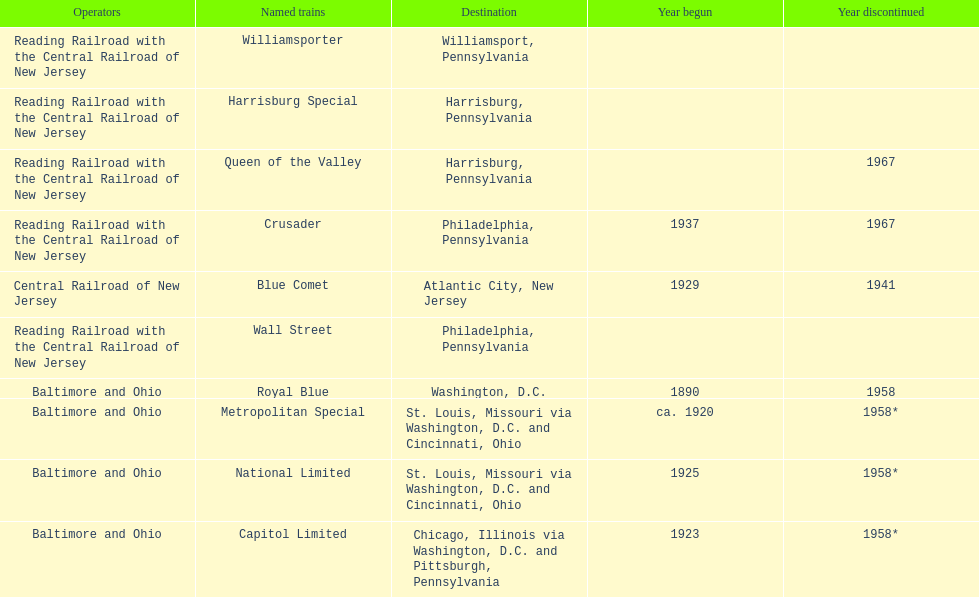What was the first train to begin service? Royal Blue. 